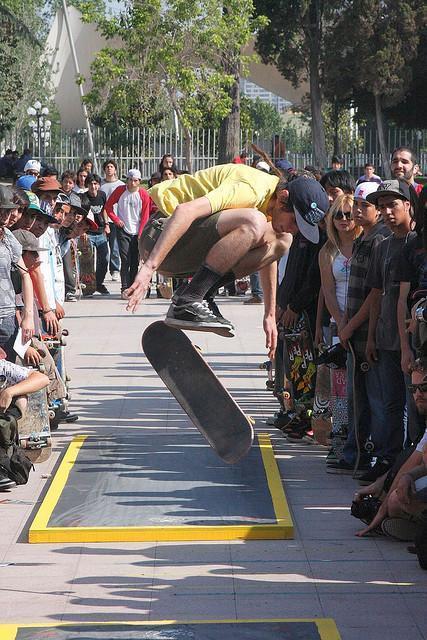How many people are there?
Give a very brief answer. 4. How many skateboards are there?
Give a very brief answer. 2. 